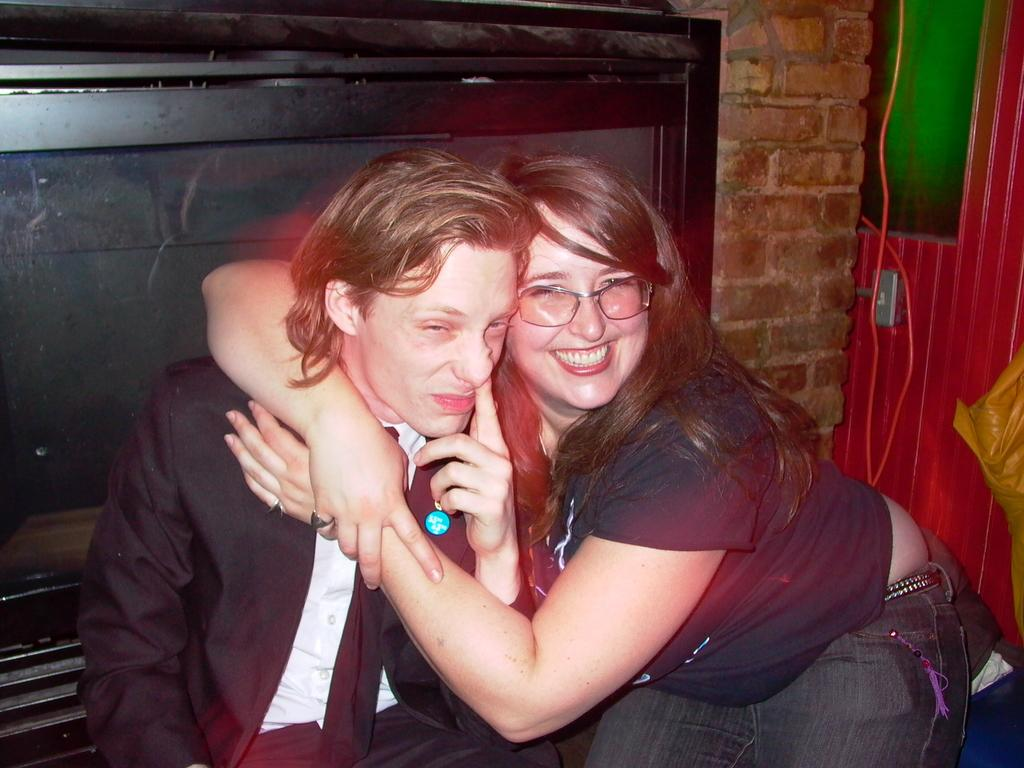How many people are in the image? There are two persons in the image. What is attached to the wall in the image? There is a T.V. attached to the wall. What can be seen on a surface in the image? There are objects on a surface in the image. What type of wire is visible in the image? There is a wire visible in the image. What color is the door in the image? There is a red door in the image. What type of polish is being applied to the rod in the image? There is no rod or polish present in the image. What type of hospital is visible in the image? There is no hospital present in the image. 